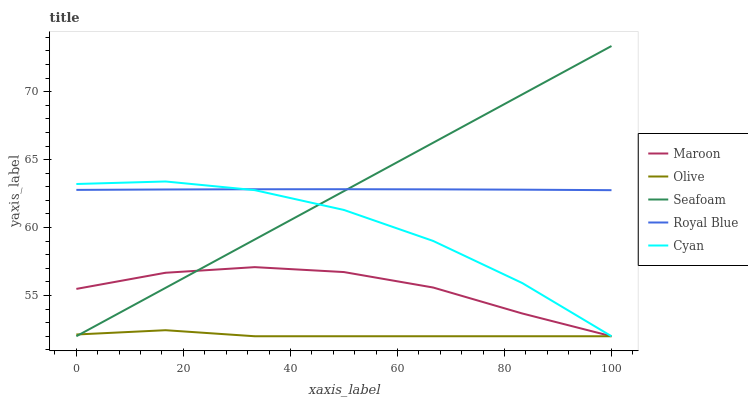Does Olive have the minimum area under the curve?
Answer yes or no. Yes. Does Royal Blue have the maximum area under the curve?
Answer yes or no. Yes. Does Seafoam have the minimum area under the curve?
Answer yes or no. No. Does Seafoam have the maximum area under the curve?
Answer yes or no. No. Is Seafoam the smoothest?
Answer yes or no. Yes. Is Cyan the roughest?
Answer yes or no. Yes. Is Royal Blue the smoothest?
Answer yes or no. No. Is Royal Blue the roughest?
Answer yes or no. No. Does Olive have the lowest value?
Answer yes or no. Yes. Does Royal Blue have the lowest value?
Answer yes or no. No. Does Seafoam have the highest value?
Answer yes or no. Yes. Does Royal Blue have the highest value?
Answer yes or no. No. Is Olive less than Royal Blue?
Answer yes or no. Yes. Is Royal Blue greater than Maroon?
Answer yes or no. Yes. Does Maroon intersect Olive?
Answer yes or no. Yes. Is Maroon less than Olive?
Answer yes or no. No. Is Maroon greater than Olive?
Answer yes or no. No. Does Olive intersect Royal Blue?
Answer yes or no. No. 